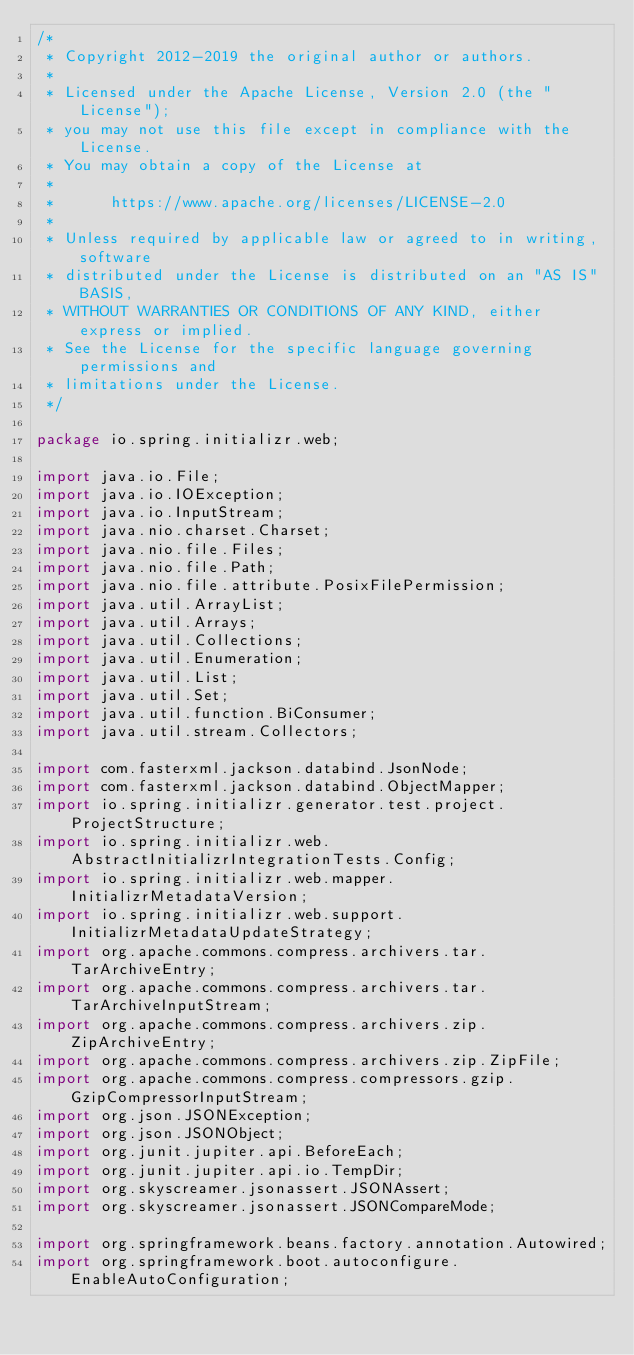Convert code to text. <code><loc_0><loc_0><loc_500><loc_500><_Java_>/*
 * Copyright 2012-2019 the original author or authors.
 *
 * Licensed under the Apache License, Version 2.0 (the "License");
 * you may not use this file except in compliance with the License.
 * You may obtain a copy of the License at
 *
 *      https://www.apache.org/licenses/LICENSE-2.0
 *
 * Unless required by applicable law or agreed to in writing, software
 * distributed under the License is distributed on an "AS IS" BASIS,
 * WITHOUT WARRANTIES OR CONDITIONS OF ANY KIND, either express or implied.
 * See the License for the specific language governing permissions and
 * limitations under the License.
 */

package io.spring.initializr.web;

import java.io.File;
import java.io.IOException;
import java.io.InputStream;
import java.nio.charset.Charset;
import java.nio.file.Files;
import java.nio.file.Path;
import java.nio.file.attribute.PosixFilePermission;
import java.util.ArrayList;
import java.util.Arrays;
import java.util.Collections;
import java.util.Enumeration;
import java.util.List;
import java.util.Set;
import java.util.function.BiConsumer;
import java.util.stream.Collectors;

import com.fasterxml.jackson.databind.JsonNode;
import com.fasterxml.jackson.databind.ObjectMapper;
import io.spring.initializr.generator.test.project.ProjectStructure;
import io.spring.initializr.web.AbstractInitializrIntegrationTests.Config;
import io.spring.initializr.web.mapper.InitializrMetadataVersion;
import io.spring.initializr.web.support.InitializrMetadataUpdateStrategy;
import org.apache.commons.compress.archivers.tar.TarArchiveEntry;
import org.apache.commons.compress.archivers.tar.TarArchiveInputStream;
import org.apache.commons.compress.archivers.zip.ZipArchiveEntry;
import org.apache.commons.compress.archivers.zip.ZipFile;
import org.apache.commons.compress.compressors.gzip.GzipCompressorInputStream;
import org.json.JSONException;
import org.json.JSONObject;
import org.junit.jupiter.api.BeforeEach;
import org.junit.jupiter.api.io.TempDir;
import org.skyscreamer.jsonassert.JSONAssert;
import org.skyscreamer.jsonassert.JSONCompareMode;

import org.springframework.beans.factory.annotation.Autowired;
import org.springframework.boot.autoconfigure.EnableAutoConfiguration;</code> 